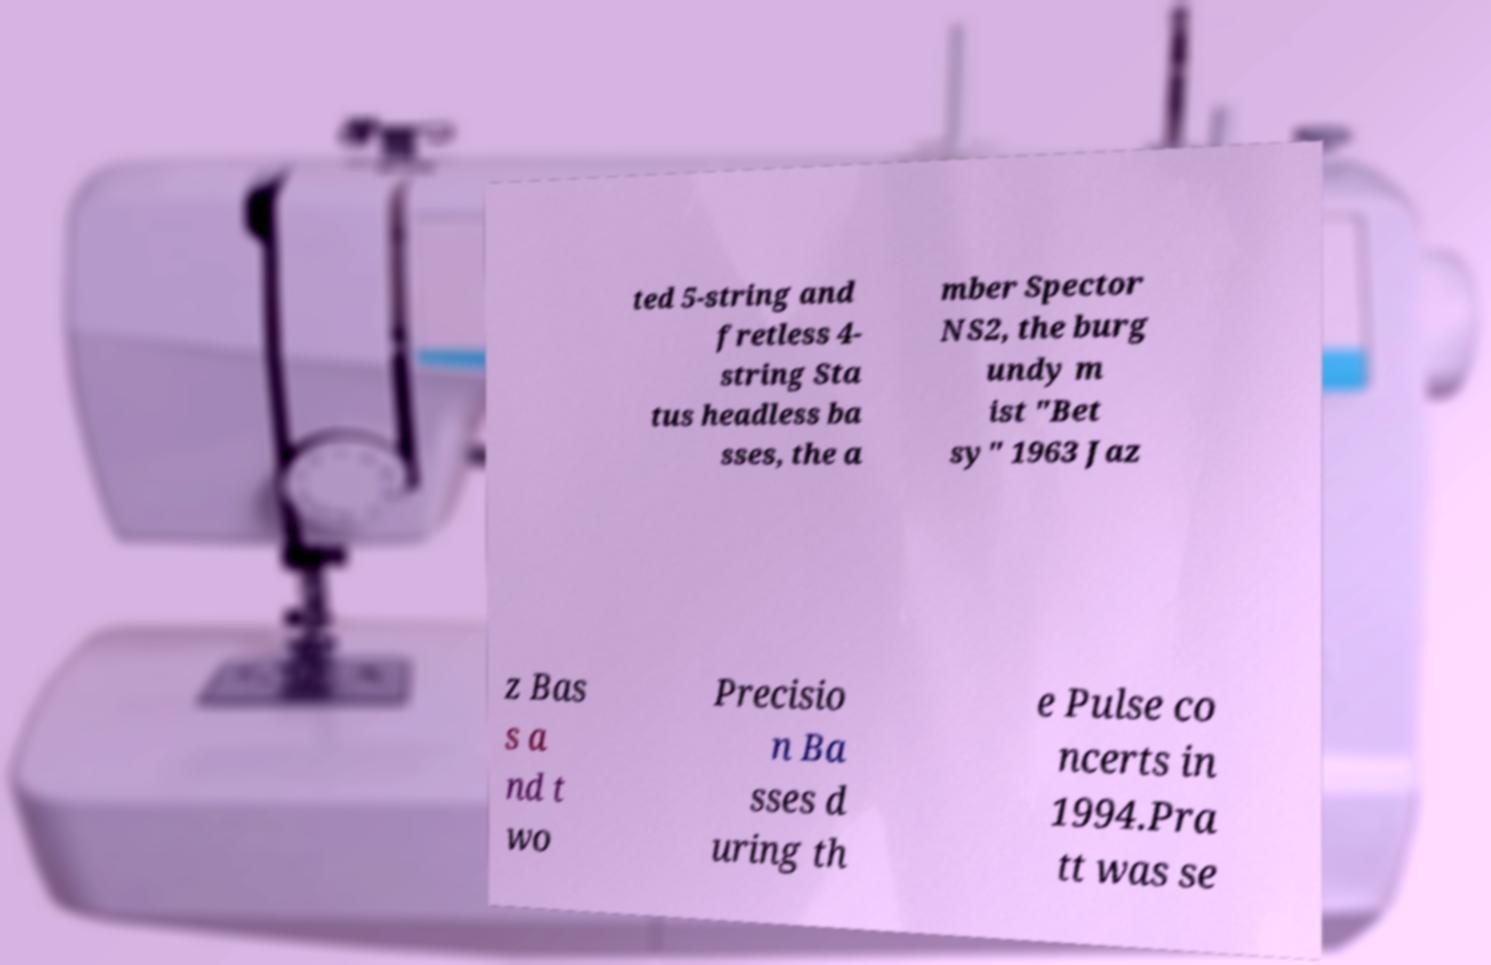Could you assist in decoding the text presented in this image and type it out clearly? ted 5-string and fretless 4- string Sta tus headless ba sses, the a mber Spector NS2, the burg undy m ist "Bet sy" 1963 Jaz z Bas s a nd t wo Precisio n Ba sses d uring th e Pulse co ncerts in 1994.Pra tt was se 